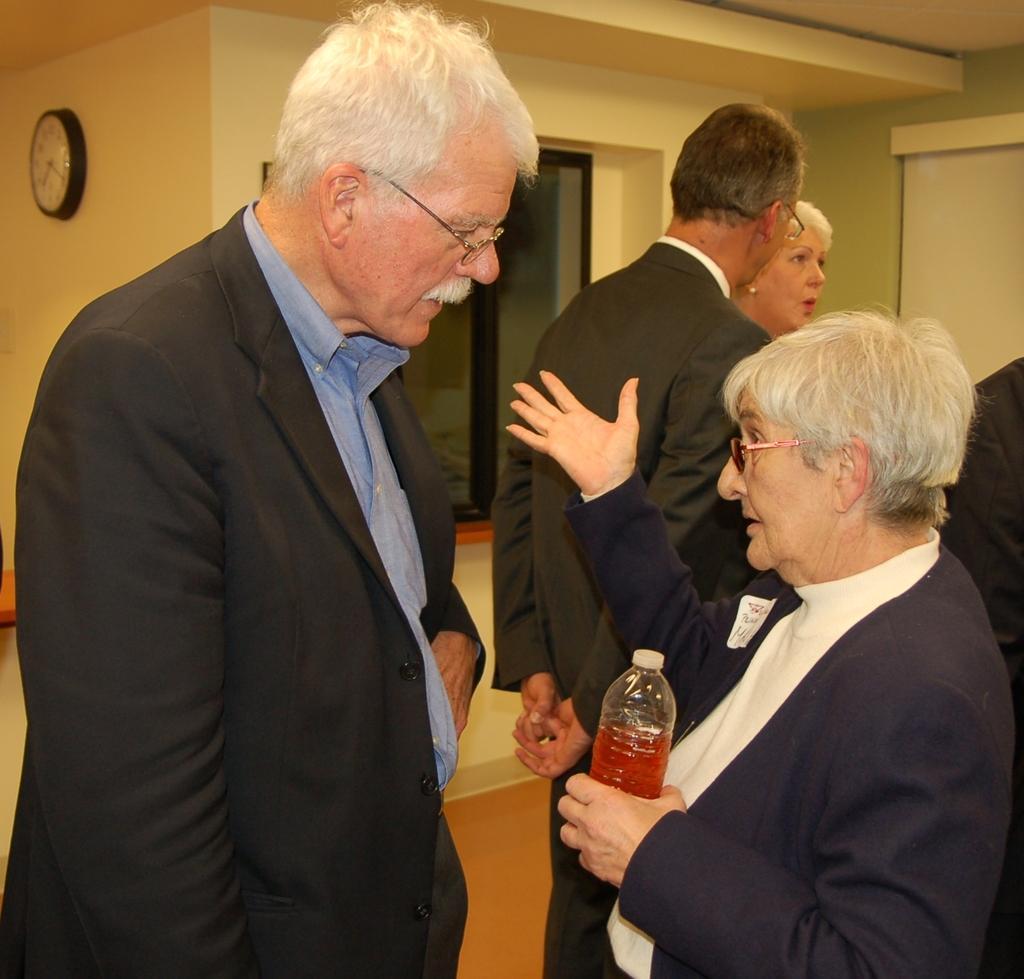Can you describe this image briefly? In the image we can see there are people who are standing and the person is holding juice bottle in her hand and on the wall there is a clock and all the people are wearing suits. 